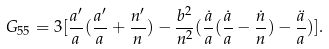Convert formula to latex. <formula><loc_0><loc_0><loc_500><loc_500>G _ { 5 5 } = 3 [ \frac { a ^ { \prime } } { a } ( \frac { a ^ { \prime } } { a } + \frac { n ^ { \prime } } { n } ) - \frac { b ^ { 2 } } { n ^ { 2 } } ( \frac { \dot { a } } { a } ( \frac { \dot { a } } { a } - \frac { \dot { n } } { n } ) - \frac { \ddot { a } } { a } ) ] .</formula> 